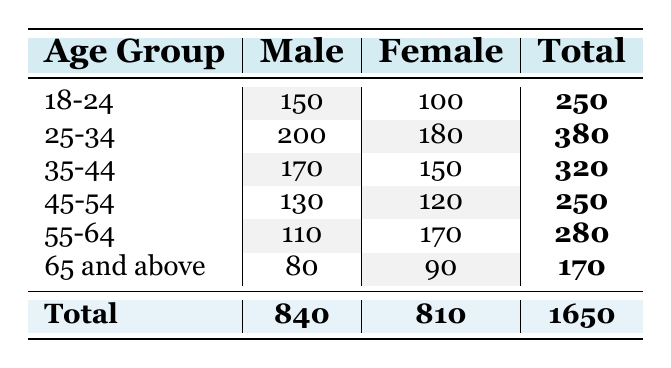What is the total number of male readers in the age group 25-34? From the table, we can directly find the value listed under the "Male" column for the age group "25-34," which is 200.
Answer: 200 How many female readers are aged 55-64? Looking at the table, we can see that the value listed under the "Female" column for the age group "55-64" is 170.
Answer: 170 What is the total number of readers aged 45-54? To find the total, we add the male and female frequencies for the age group "45-54," which are 130 and 120. So, 130 + 120 = 250.
Answer: 250 Is the number of male readers in the age group 35-44 greater than the number of female readers in the same age group? The table shows that there are 170 male readers and 150 female readers in the age group "35-44." Since 170 is greater than 150, the answer is yes.
Answer: Yes What is the difference in the number of male and female readers in the age group 18-24? For the age group "18-24," there are 150 male and 100 female readers. The difference is calculated as 150 - 100 = 50.
Answer: 50 What percentage of the total readers are female? The total number of readers is 1650. The number of female readers is 810. To find the percentage, we calculate (810 / 1650) * 100, which equals approximately 49.09%.
Answer: 49.09% How does the number of male readers in the age group 65 and above compare to the number of male readers aged 18-24? The number of male readers aged 65 and above is 80, while those aged 18-24 are 150. Since 150 is greater than 80, this suggests that male readers are more prevalent in the younger age group.
Answer: 150 > 80 